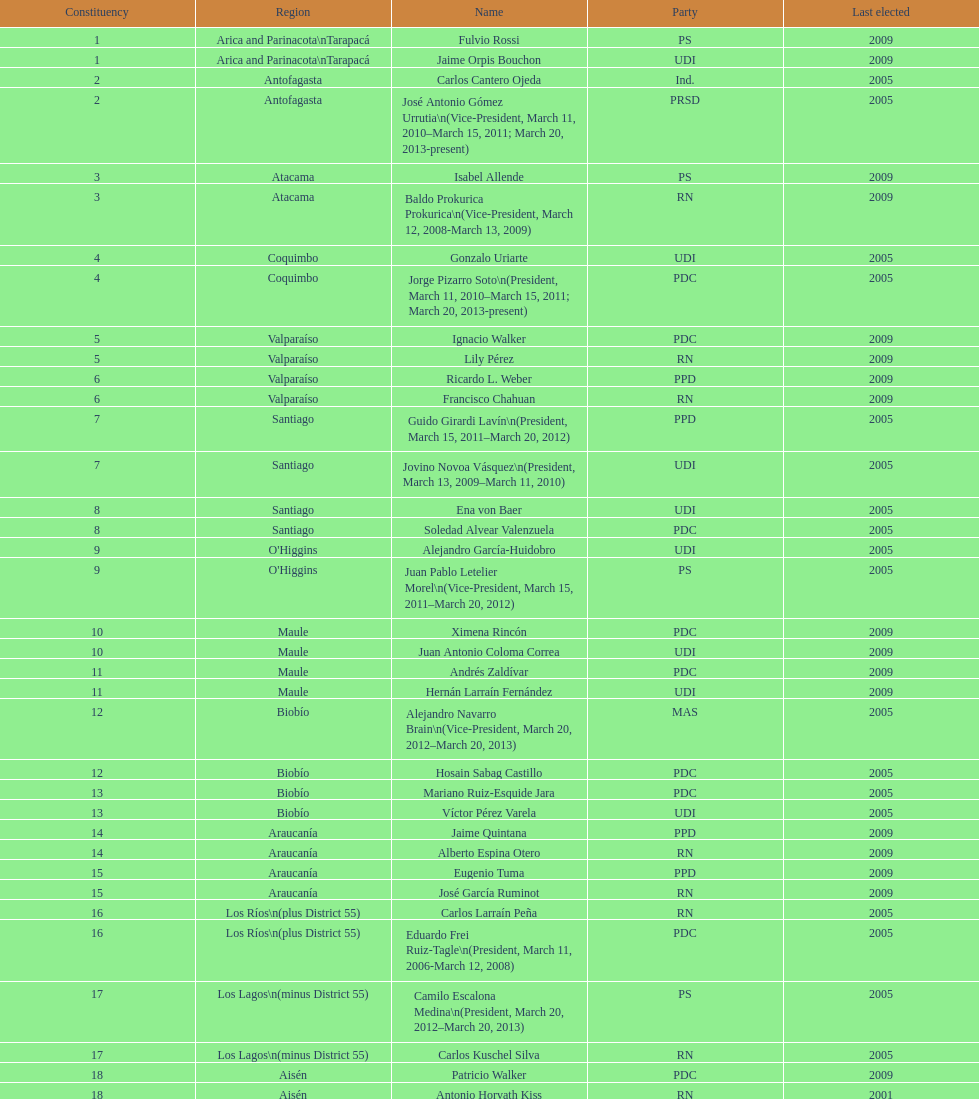In the table, which region is listed at the end? Magallanes. 